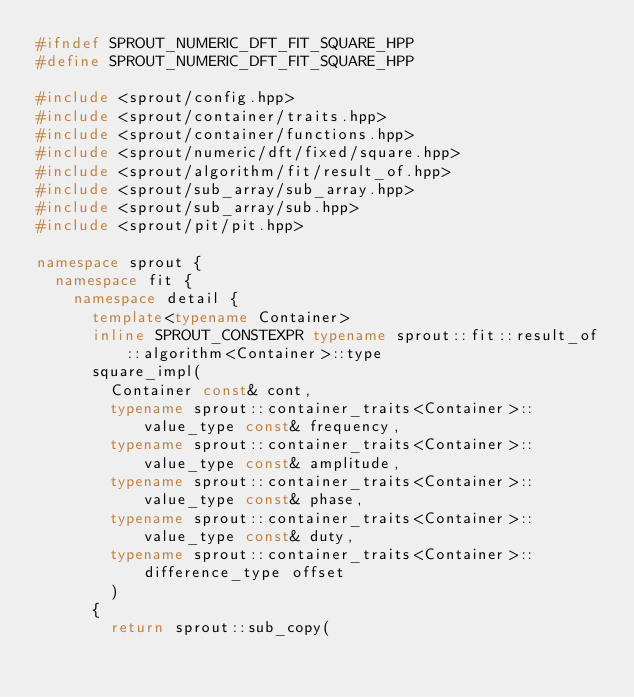Convert code to text. <code><loc_0><loc_0><loc_500><loc_500><_C++_>#ifndef SPROUT_NUMERIC_DFT_FIT_SQUARE_HPP
#define SPROUT_NUMERIC_DFT_FIT_SQUARE_HPP

#include <sprout/config.hpp>
#include <sprout/container/traits.hpp>
#include <sprout/container/functions.hpp>
#include <sprout/numeric/dft/fixed/square.hpp>
#include <sprout/algorithm/fit/result_of.hpp>
#include <sprout/sub_array/sub_array.hpp>
#include <sprout/sub_array/sub.hpp>
#include <sprout/pit/pit.hpp>

namespace sprout {
	namespace fit {
		namespace detail {
			template<typename Container>
			inline SPROUT_CONSTEXPR typename sprout::fit::result_of::algorithm<Container>::type
			square_impl(
				Container const& cont,
				typename sprout::container_traits<Container>::value_type const& frequency,
				typename sprout::container_traits<Container>::value_type const& amplitude,
				typename sprout::container_traits<Container>::value_type const& phase,
				typename sprout::container_traits<Container>::value_type const& duty,
				typename sprout::container_traits<Container>::difference_type offset
				)
			{
				return sprout::sub_copy(</code> 